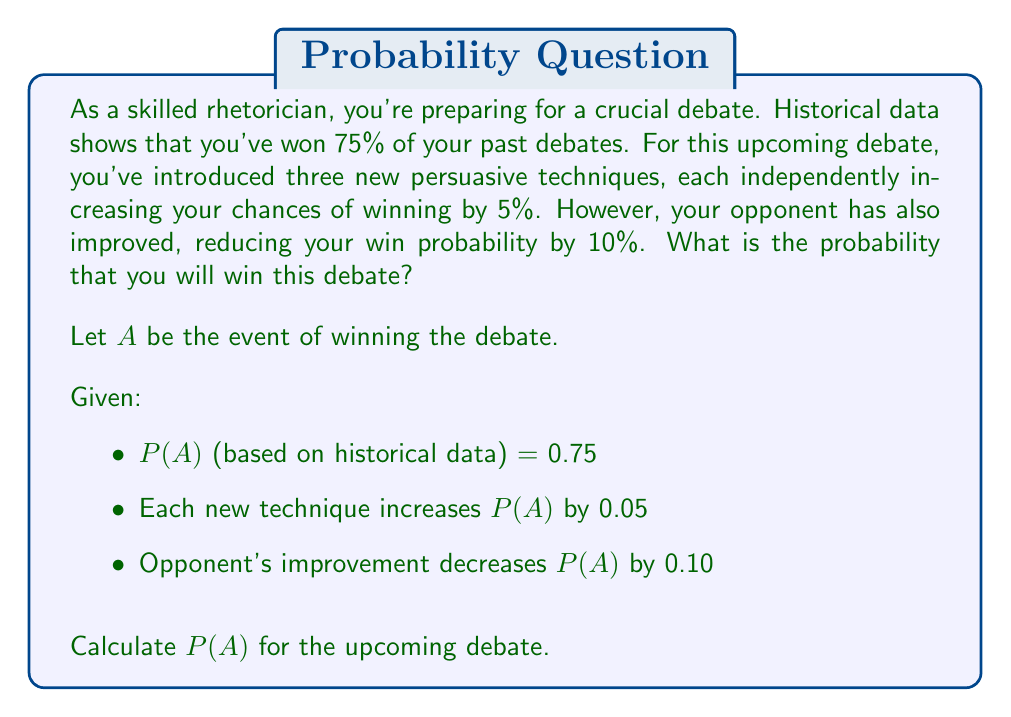Could you help me with this problem? To solve this problem, we'll follow these steps:

1) Start with the base probability from historical data:
   $P(A) = 0.75$

2) Add the effect of the three new techniques:
   Each technique increases the probability by 0.05
   Total increase: $3 \times 0.05 = 0.15$
   
   New probability: $0.75 + 0.15 = 0.90$

3) Subtract the effect of the opponent's improvement:
   Opponent's improvement decreases the probability by 0.10
   
   Final probability: $0.90 - 0.10 = 0.80$

However, we need to ensure that our probability remains within the valid range of [0, 1].

In this case, $0.80$ is a valid probability, so no further adjustment is needed.

Therefore, the probability of winning the upcoming debate is 0.80 or 80%.

Note: This calculation assumes that the effects are additive and independent. In a real-world scenario, the interactions between these factors might be more complex.
Answer: The probability of winning the upcoming debate is 0.80 or 80%. 